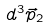Convert formula to latex. <formula><loc_0><loc_0><loc_500><loc_500>d ^ { 3 } \vec { p } _ { 2 }</formula> 